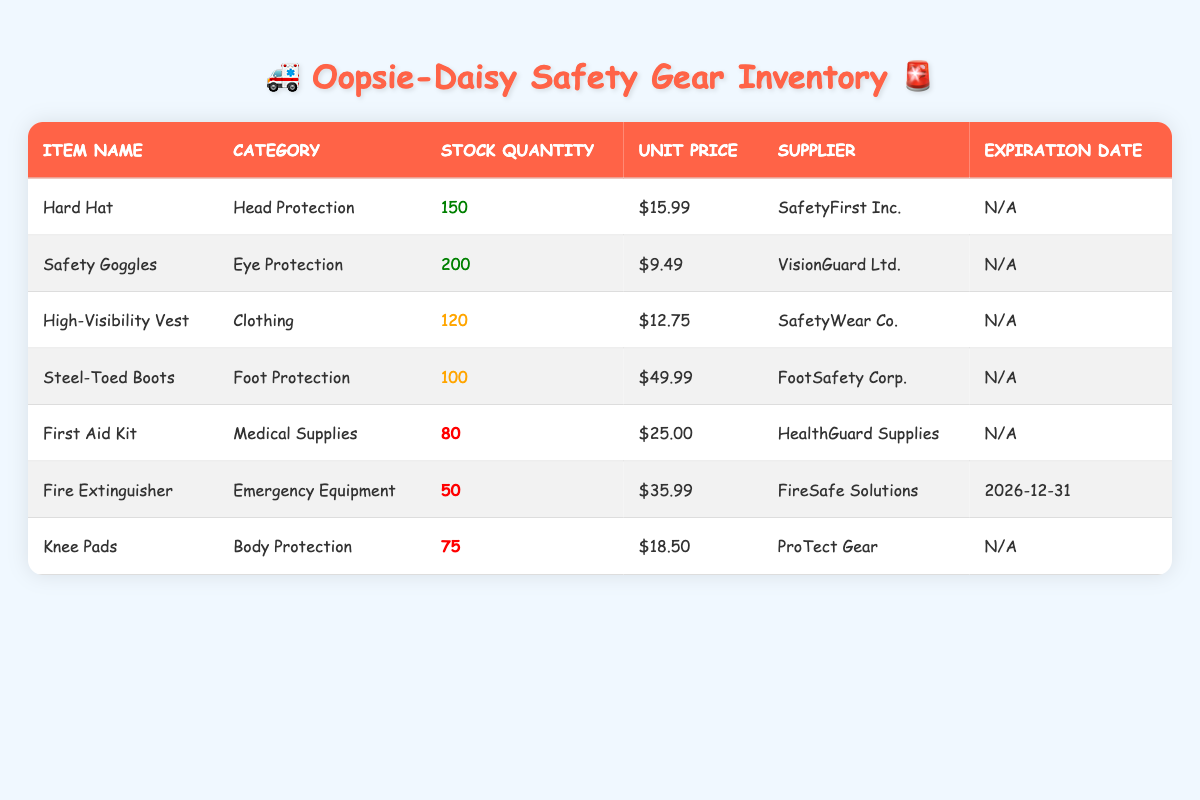What is the stock quantity of Safety Goggles? The table lists the stock quantity for Safety Goggles under the "Stock Quantity" column. It shows that there are 200 units available.
Answer: 200 How much do Steel-Toed Boots cost? The unit price for Steel-Toed Boots is shown in the "Unit Price" column of the table. It is listed as $49.99.
Answer: $49.99 Is the First Aid Kit more expensive than the Fire Extinguisher? The unit price of the First Aid Kit is $25.00, while the Fire Extinguisher costs $35.99. Since $25.00 is less than $35.99, the answer is no.
Answer: No How many items have a stock quantity less than 100? By reviewing the "Stock Quantity" column, we see that the First Aid Kit (80), Fire Extinguisher (50), and Knee Pads (75) all have stock quantities less than 100. This totals to 3 items.
Answer: 3 Which supplier provides High-Visibility Vests? The supplier for High-Visibility Vests can be found in the "Supplier" column next to the item name High-Visibility Vest. It states that SafetyWear Co. is the supplier.
Answer: SafetyWear Co What is the total stock quantity of all items listed? We sum the stock quantities of all items: 150 (Hard Hat) + 200 (Safety Goggles) + 120 (High-Visibility Vest) + 100 (Steel-Toed Boots) + 80 (First Aid Kit) + 50 (Fire Extinguisher) + 75 (Knee Pads) = 875.
Answer: 875 Are there any items that expire soon? The "Expiration Date" column shows that only the Fire Extinguisher has an expiration date, set for December 31, 2026. Since there are items without an expiration date, the answer is yes.
Answer: Yes What is the average unit price of all items? To find the average unit price, we first calculate the total unit prices: $15.99 + $9.49 + $12.75 + $49.99 + $25.00 + $35.99 + $18.50 = $172.71. Then we divide by the total number of items (7): $172.71 / 7 = approximately $24.39.
Answer: $24.39 How many categories of protective equipment are represented in the inventory? The categories are Head Protection, Eye Protection, Clothing, Foot Protection, Medical Supplies, Emergency Equipment, and Body Protection. Counting these distinct categories, we find there are 7 different categories represented.
Answer: 7 